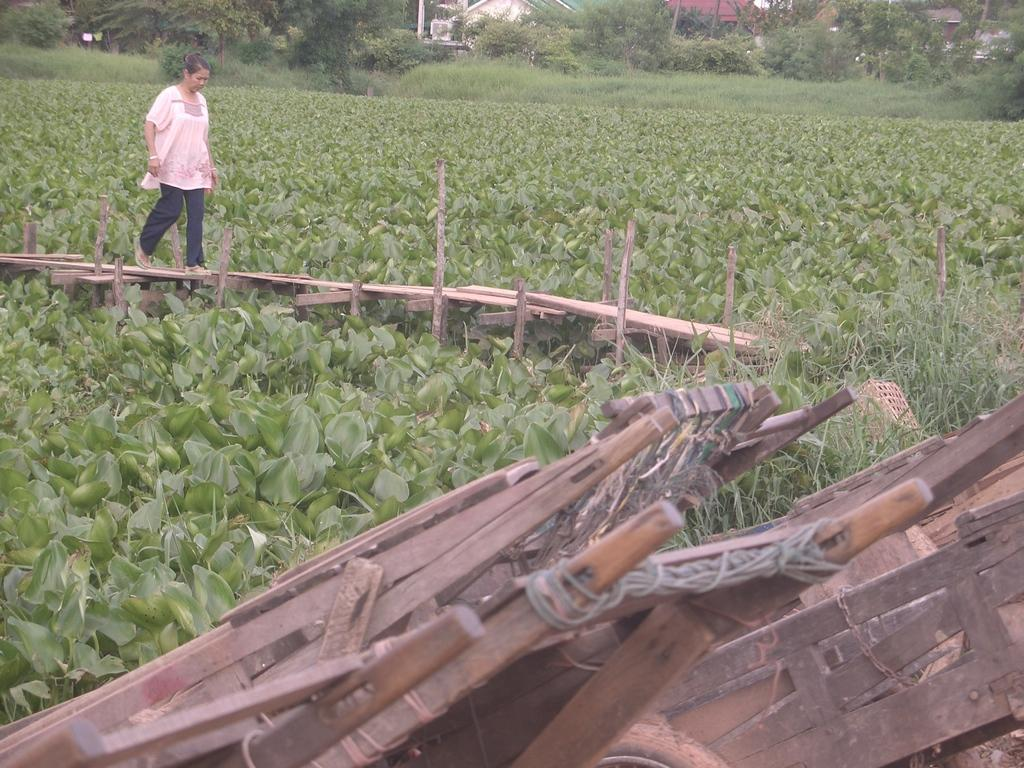What is the lady in the image doing? The lady is walking in the image. On what surface is the lady walking? The lady is walking on a wooden path. What type of vegetation can be seen in the image? There are plants, trees, and grass in the image. What type of structures are visible in the image? There are houses in the image. What material is used for some objects in the image? There are wooden objects in the image. How many ducks are swimming in the basin in the image? There is no basin or ducks present in the image. 